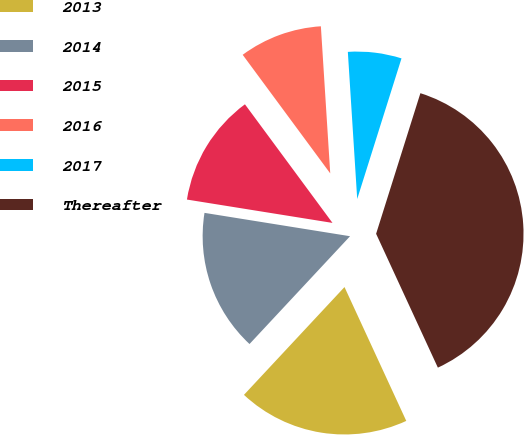Convert chart to OTSL. <chart><loc_0><loc_0><loc_500><loc_500><pie_chart><fcel>2013<fcel>2014<fcel>2015<fcel>2016<fcel>2017<fcel>Thereafter<nl><fcel>18.83%<fcel>15.59%<fcel>12.35%<fcel>9.11%<fcel>5.87%<fcel>38.27%<nl></chart> 